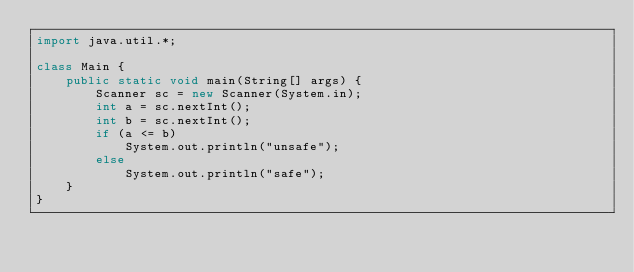<code> <loc_0><loc_0><loc_500><loc_500><_Java_>import java.util.*;

class Main {
    public static void main(String[] args) {
        Scanner sc = new Scanner(System.in);
        int a = sc.nextInt();
        int b = sc.nextInt();
        if (a <= b)
            System.out.println("unsafe");
        else
            System.out.println("safe");
    }
}</code> 